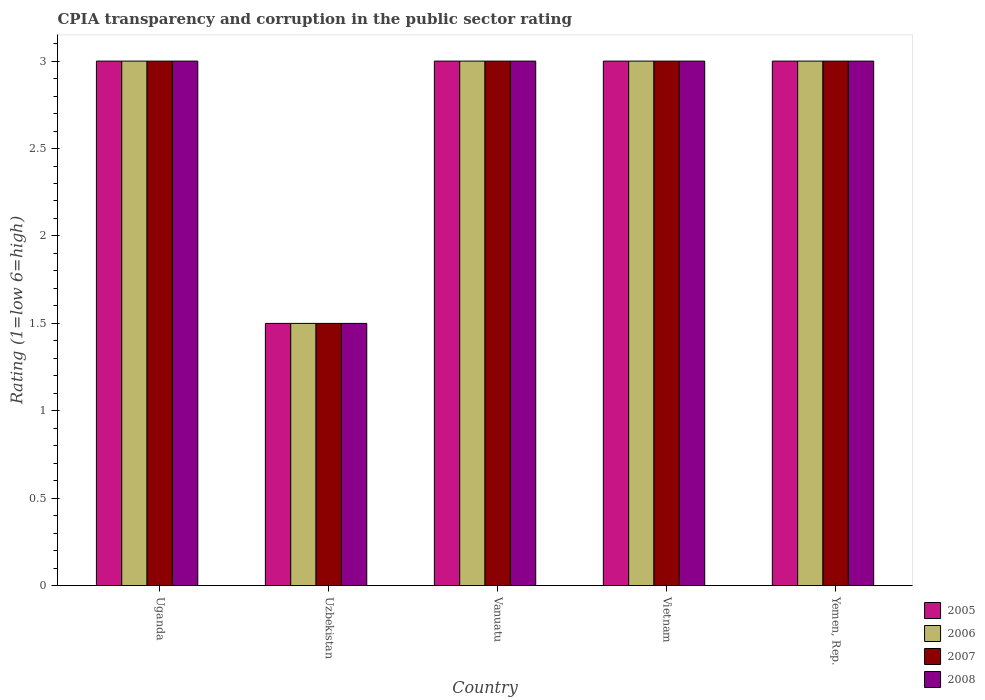How many different coloured bars are there?
Give a very brief answer. 4. Are the number of bars per tick equal to the number of legend labels?
Provide a succinct answer. Yes. How many bars are there on the 2nd tick from the left?
Your answer should be very brief. 4. How many bars are there on the 5th tick from the right?
Your answer should be very brief. 4. What is the label of the 2nd group of bars from the left?
Offer a very short reply. Uzbekistan. What is the CPIA rating in 2006 in Uganda?
Your answer should be very brief. 3. Across all countries, what is the maximum CPIA rating in 2006?
Your answer should be very brief. 3. Across all countries, what is the minimum CPIA rating in 2008?
Give a very brief answer. 1.5. In which country was the CPIA rating in 2007 maximum?
Make the answer very short. Uganda. In which country was the CPIA rating in 2007 minimum?
Give a very brief answer. Uzbekistan. What is the difference between the CPIA rating in 2007 in Yemen, Rep. and the CPIA rating in 2006 in Uzbekistan?
Keep it short and to the point. 1.5. In how many countries, is the CPIA rating in 2007 greater than 2.3?
Offer a very short reply. 4. What is the ratio of the CPIA rating in 2005 in Uganda to that in Vietnam?
Your answer should be very brief. 1. Is the CPIA rating in 2006 in Uganda less than that in Vietnam?
Offer a terse response. No. What is the difference between the highest and the lowest CPIA rating in 2005?
Give a very brief answer. 1.5. Is the sum of the CPIA rating in 2007 in Uganda and Uzbekistan greater than the maximum CPIA rating in 2006 across all countries?
Make the answer very short. Yes. How many bars are there?
Make the answer very short. 20. Are all the bars in the graph horizontal?
Offer a terse response. No. How many countries are there in the graph?
Give a very brief answer. 5. What is the difference between two consecutive major ticks on the Y-axis?
Provide a short and direct response. 0.5. Does the graph contain grids?
Give a very brief answer. No. How many legend labels are there?
Make the answer very short. 4. How are the legend labels stacked?
Make the answer very short. Vertical. What is the title of the graph?
Your answer should be compact. CPIA transparency and corruption in the public sector rating. Does "1989" appear as one of the legend labels in the graph?
Provide a short and direct response. No. What is the Rating (1=low 6=high) of 2005 in Uganda?
Give a very brief answer. 3. What is the Rating (1=low 6=high) in 2007 in Uganda?
Ensure brevity in your answer.  3. What is the Rating (1=low 6=high) in 2006 in Uzbekistan?
Your answer should be very brief. 1.5. What is the Rating (1=low 6=high) in 2005 in Vanuatu?
Give a very brief answer. 3. What is the Rating (1=low 6=high) of 2006 in Vanuatu?
Offer a very short reply. 3. What is the Rating (1=low 6=high) in 2007 in Vanuatu?
Your response must be concise. 3. What is the Rating (1=low 6=high) of 2008 in Vanuatu?
Offer a terse response. 3. What is the Rating (1=low 6=high) of 2007 in Vietnam?
Offer a terse response. 3. What is the Rating (1=low 6=high) in 2006 in Yemen, Rep.?
Provide a short and direct response. 3. Across all countries, what is the maximum Rating (1=low 6=high) of 2005?
Your answer should be very brief. 3. Across all countries, what is the maximum Rating (1=low 6=high) of 2007?
Ensure brevity in your answer.  3. Across all countries, what is the maximum Rating (1=low 6=high) of 2008?
Your response must be concise. 3. Across all countries, what is the minimum Rating (1=low 6=high) of 2005?
Keep it short and to the point. 1.5. Across all countries, what is the minimum Rating (1=low 6=high) in 2007?
Your answer should be compact. 1.5. Across all countries, what is the minimum Rating (1=low 6=high) of 2008?
Give a very brief answer. 1.5. What is the total Rating (1=low 6=high) of 2005 in the graph?
Offer a very short reply. 13.5. What is the total Rating (1=low 6=high) of 2006 in the graph?
Your answer should be compact. 13.5. What is the total Rating (1=low 6=high) in 2008 in the graph?
Make the answer very short. 13.5. What is the difference between the Rating (1=low 6=high) of 2006 in Uganda and that in Uzbekistan?
Offer a terse response. 1.5. What is the difference between the Rating (1=low 6=high) of 2007 in Uganda and that in Uzbekistan?
Provide a succinct answer. 1.5. What is the difference between the Rating (1=low 6=high) of 2008 in Uganda and that in Uzbekistan?
Give a very brief answer. 1.5. What is the difference between the Rating (1=low 6=high) in 2008 in Uganda and that in Vanuatu?
Your response must be concise. 0. What is the difference between the Rating (1=low 6=high) of 2006 in Uganda and that in Yemen, Rep.?
Ensure brevity in your answer.  0. What is the difference between the Rating (1=low 6=high) in 2007 in Uganda and that in Yemen, Rep.?
Ensure brevity in your answer.  0. What is the difference between the Rating (1=low 6=high) in 2008 in Uganda and that in Yemen, Rep.?
Your response must be concise. 0. What is the difference between the Rating (1=low 6=high) in 2006 in Uzbekistan and that in Vanuatu?
Offer a very short reply. -1.5. What is the difference between the Rating (1=low 6=high) of 2008 in Uzbekistan and that in Vanuatu?
Provide a short and direct response. -1.5. What is the difference between the Rating (1=low 6=high) in 2006 in Uzbekistan and that in Vietnam?
Your response must be concise. -1.5. What is the difference between the Rating (1=low 6=high) in 2006 in Uzbekistan and that in Yemen, Rep.?
Provide a succinct answer. -1.5. What is the difference between the Rating (1=low 6=high) of 2007 in Uzbekistan and that in Yemen, Rep.?
Keep it short and to the point. -1.5. What is the difference between the Rating (1=low 6=high) of 2006 in Vanuatu and that in Vietnam?
Keep it short and to the point. 0. What is the difference between the Rating (1=low 6=high) in 2007 in Vanuatu and that in Vietnam?
Keep it short and to the point. 0. What is the difference between the Rating (1=low 6=high) of 2008 in Vanuatu and that in Vietnam?
Your response must be concise. 0. What is the difference between the Rating (1=low 6=high) of 2005 in Vanuatu and that in Yemen, Rep.?
Give a very brief answer. 0. What is the difference between the Rating (1=low 6=high) in 2006 in Vanuatu and that in Yemen, Rep.?
Provide a short and direct response. 0. What is the difference between the Rating (1=low 6=high) in 2005 in Vietnam and that in Yemen, Rep.?
Keep it short and to the point. 0. What is the difference between the Rating (1=low 6=high) in 2006 in Vietnam and that in Yemen, Rep.?
Make the answer very short. 0. What is the difference between the Rating (1=low 6=high) of 2005 in Uganda and the Rating (1=low 6=high) of 2006 in Uzbekistan?
Your answer should be very brief. 1.5. What is the difference between the Rating (1=low 6=high) in 2005 in Uganda and the Rating (1=low 6=high) in 2008 in Uzbekistan?
Ensure brevity in your answer.  1.5. What is the difference between the Rating (1=low 6=high) in 2006 in Uganda and the Rating (1=low 6=high) in 2008 in Uzbekistan?
Your answer should be very brief. 1.5. What is the difference between the Rating (1=low 6=high) in 2007 in Uganda and the Rating (1=low 6=high) in 2008 in Uzbekistan?
Give a very brief answer. 1.5. What is the difference between the Rating (1=low 6=high) in 2005 in Uganda and the Rating (1=low 6=high) in 2006 in Vanuatu?
Ensure brevity in your answer.  0. What is the difference between the Rating (1=low 6=high) in 2005 in Uganda and the Rating (1=low 6=high) in 2008 in Vanuatu?
Ensure brevity in your answer.  0. What is the difference between the Rating (1=low 6=high) of 2006 in Uganda and the Rating (1=low 6=high) of 2008 in Vanuatu?
Keep it short and to the point. 0. What is the difference between the Rating (1=low 6=high) in 2005 in Uganda and the Rating (1=low 6=high) in 2008 in Vietnam?
Your answer should be very brief. 0. What is the difference between the Rating (1=low 6=high) of 2006 in Uganda and the Rating (1=low 6=high) of 2007 in Vietnam?
Ensure brevity in your answer.  0. What is the difference between the Rating (1=low 6=high) in 2006 in Uganda and the Rating (1=low 6=high) in 2008 in Vietnam?
Offer a terse response. 0. What is the difference between the Rating (1=low 6=high) in 2005 in Uganda and the Rating (1=low 6=high) in 2007 in Yemen, Rep.?
Make the answer very short. 0. What is the difference between the Rating (1=low 6=high) in 2005 in Uganda and the Rating (1=low 6=high) in 2008 in Yemen, Rep.?
Your response must be concise. 0. What is the difference between the Rating (1=low 6=high) of 2006 in Uganda and the Rating (1=low 6=high) of 2007 in Yemen, Rep.?
Your response must be concise. 0. What is the difference between the Rating (1=low 6=high) of 2006 in Uganda and the Rating (1=low 6=high) of 2008 in Yemen, Rep.?
Your answer should be very brief. 0. What is the difference between the Rating (1=low 6=high) of 2005 in Uzbekistan and the Rating (1=low 6=high) of 2007 in Vanuatu?
Your answer should be very brief. -1.5. What is the difference between the Rating (1=low 6=high) in 2005 in Uzbekistan and the Rating (1=low 6=high) in 2008 in Vanuatu?
Your answer should be compact. -1.5. What is the difference between the Rating (1=low 6=high) in 2006 in Uzbekistan and the Rating (1=low 6=high) in 2007 in Vanuatu?
Your answer should be very brief. -1.5. What is the difference between the Rating (1=low 6=high) of 2007 in Uzbekistan and the Rating (1=low 6=high) of 2008 in Vanuatu?
Provide a succinct answer. -1.5. What is the difference between the Rating (1=low 6=high) in 2005 in Uzbekistan and the Rating (1=low 6=high) in 2006 in Vietnam?
Offer a terse response. -1.5. What is the difference between the Rating (1=low 6=high) in 2005 in Uzbekistan and the Rating (1=low 6=high) in 2008 in Vietnam?
Provide a short and direct response. -1.5. What is the difference between the Rating (1=low 6=high) in 2006 in Uzbekistan and the Rating (1=low 6=high) in 2007 in Vietnam?
Offer a very short reply. -1.5. What is the difference between the Rating (1=low 6=high) in 2005 in Uzbekistan and the Rating (1=low 6=high) in 2007 in Yemen, Rep.?
Keep it short and to the point. -1.5. What is the difference between the Rating (1=low 6=high) of 2005 in Uzbekistan and the Rating (1=low 6=high) of 2008 in Yemen, Rep.?
Your answer should be very brief. -1.5. What is the difference between the Rating (1=low 6=high) in 2005 in Vanuatu and the Rating (1=low 6=high) in 2007 in Vietnam?
Ensure brevity in your answer.  0. What is the difference between the Rating (1=low 6=high) of 2005 in Vanuatu and the Rating (1=low 6=high) of 2008 in Vietnam?
Offer a very short reply. 0. What is the difference between the Rating (1=low 6=high) of 2006 in Vanuatu and the Rating (1=low 6=high) of 2007 in Vietnam?
Your answer should be compact. 0. What is the difference between the Rating (1=low 6=high) of 2007 in Vanuatu and the Rating (1=low 6=high) of 2008 in Vietnam?
Your response must be concise. 0. What is the difference between the Rating (1=low 6=high) of 2005 in Vanuatu and the Rating (1=low 6=high) of 2006 in Yemen, Rep.?
Your answer should be compact. 0. What is the difference between the Rating (1=low 6=high) of 2005 in Vanuatu and the Rating (1=low 6=high) of 2007 in Yemen, Rep.?
Make the answer very short. 0. What is the difference between the Rating (1=low 6=high) of 2005 in Vanuatu and the Rating (1=low 6=high) of 2008 in Yemen, Rep.?
Your response must be concise. 0. What is the difference between the Rating (1=low 6=high) in 2006 in Vanuatu and the Rating (1=low 6=high) in 2007 in Yemen, Rep.?
Make the answer very short. 0. What is the difference between the Rating (1=low 6=high) of 2006 in Vanuatu and the Rating (1=low 6=high) of 2008 in Yemen, Rep.?
Make the answer very short. 0. What is the difference between the Rating (1=low 6=high) of 2007 in Vanuatu and the Rating (1=low 6=high) of 2008 in Yemen, Rep.?
Give a very brief answer. 0. What is the difference between the Rating (1=low 6=high) in 2005 in Vietnam and the Rating (1=low 6=high) in 2006 in Yemen, Rep.?
Offer a very short reply. 0. What is the difference between the Rating (1=low 6=high) of 2006 in Vietnam and the Rating (1=low 6=high) of 2007 in Yemen, Rep.?
Offer a very short reply. 0. What is the difference between the Rating (1=low 6=high) in 2007 in Vietnam and the Rating (1=low 6=high) in 2008 in Yemen, Rep.?
Your answer should be compact. 0. What is the average Rating (1=low 6=high) in 2005 per country?
Offer a terse response. 2.7. What is the difference between the Rating (1=low 6=high) in 2005 and Rating (1=low 6=high) in 2006 in Uganda?
Offer a very short reply. 0. What is the difference between the Rating (1=low 6=high) in 2005 and Rating (1=low 6=high) in 2007 in Uganda?
Your answer should be compact. 0. What is the difference between the Rating (1=low 6=high) of 2007 and Rating (1=low 6=high) of 2008 in Uganda?
Provide a succinct answer. 0. What is the difference between the Rating (1=low 6=high) in 2005 and Rating (1=low 6=high) in 2006 in Uzbekistan?
Ensure brevity in your answer.  0. What is the difference between the Rating (1=low 6=high) of 2005 and Rating (1=low 6=high) of 2007 in Uzbekistan?
Your answer should be compact. 0. What is the difference between the Rating (1=low 6=high) of 2005 and Rating (1=low 6=high) of 2008 in Uzbekistan?
Offer a very short reply. 0. What is the difference between the Rating (1=low 6=high) in 2006 and Rating (1=low 6=high) in 2008 in Uzbekistan?
Keep it short and to the point. 0. What is the difference between the Rating (1=low 6=high) in 2005 and Rating (1=low 6=high) in 2007 in Vanuatu?
Keep it short and to the point. 0. What is the difference between the Rating (1=low 6=high) in 2005 and Rating (1=low 6=high) in 2008 in Vietnam?
Your answer should be very brief. 0. What is the difference between the Rating (1=low 6=high) of 2006 and Rating (1=low 6=high) of 2007 in Vietnam?
Offer a very short reply. 0. What is the difference between the Rating (1=low 6=high) in 2006 and Rating (1=low 6=high) in 2008 in Vietnam?
Offer a terse response. 0. What is the difference between the Rating (1=low 6=high) of 2005 and Rating (1=low 6=high) of 2006 in Yemen, Rep.?
Give a very brief answer. 0. What is the difference between the Rating (1=low 6=high) of 2005 and Rating (1=low 6=high) of 2008 in Yemen, Rep.?
Your response must be concise. 0. What is the difference between the Rating (1=low 6=high) in 2006 and Rating (1=low 6=high) in 2007 in Yemen, Rep.?
Offer a terse response. 0. What is the difference between the Rating (1=low 6=high) in 2007 and Rating (1=low 6=high) in 2008 in Yemen, Rep.?
Keep it short and to the point. 0. What is the ratio of the Rating (1=low 6=high) of 2005 in Uganda to that in Uzbekistan?
Make the answer very short. 2. What is the ratio of the Rating (1=low 6=high) of 2006 in Uganda to that in Uzbekistan?
Offer a terse response. 2. What is the ratio of the Rating (1=low 6=high) in 2008 in Uganda to that in Uzbekistan?
Offer a terse response. 2. What is the ratio of the Rating (1=low 6=high) in 2005 in Uganda to that in Vanuatu?
Provide a succinct answer. 1. What is the ratio of the Rating (1=low 6=high) in 2007 in Uganda to that in Vanuatu?
Offer a terse response. 1. What is the ratio of the Rating (1=low 6=high) of 2008 in Uganda to that in Vanuatu?
Your response must be concise. 1. What is the ratio of the Rating (1=low 6=high) in 2005 in Uganda to that in Yemen, Rep.?
Offer a very short reply. 1. What is the ratio of the Rating (1=low 6=high) in 2007 in Uganda to that in Yemen, Rep.?
Provide a succinct answer. 1. What is the ratio of the Rating (1=low 6=high) of 2008 in Uganda to that in Yemen, Rep.?
Offer a terse response. 1. What is the ratio of the Rating (1=low 6=high) in 2005 in Uzbekistan to that in Vanuatu?
Your answer should be compact. 0.5. What is the ratio of the Rating (1=low 6=high) of 2008 in Uzbekistan to that in Vanuatu?
Offer a terse response. 0.5. What is the ratio of the Rating (1=low 6=high) in 2005 in Uzbekistan to that in Vietnam?
Make the answer very short. 0.5. What is the ratio of the Rating (1=low 6=high) of 2006 in Uzbekistan to that in Vietnam?
Offer a very short reply. 0.5. What is the ratio of the Rating (1=low 6=high) in 2008 in Uzbekistan to that in Vietnam?
Give a very brief answer. 0.5. What is the ratio of the Rating (1=low 6=high) of 2007 in Uzbekistan to that in Yemen, Rep.?
Offer a very short reply. 0.5. What is the ratio of the Rating (1=low 6=high) of 2008 in Uzbekistan to that in Yemen, Rep.?
Your answer should be compact. 0.5. What is the ratio of the Rating (1=low 6=high) in 2007 in Vanuatu to that in Vietnam?
Give a very brief answer. 1. What is the ratio of the Rating (1=low 6=high) of 2008 in Vanuatu to that in Vietnam?
Give a very brief answer. 1. What is the ratio of the Rating (1=low 6=high) of 2007 in Vanuatu to that in Yemen, Rep.?
Keep it short and to the point. 1. What is the ratio of the Rating (1=low 6=high) in 2006 in Vietnam to that in Yemen, Rep.?
Offer a terse response. 1. What is the difference between the highest and the second highest Rating (1=low 6=high) in 2005?
Offer a terse response. 0. What is the difference between the highest and the second highest Rating (1=low 6=high) in 2006?
Provide a short and direct response. 0. What is the difference between the highest and the second highest Rating (1=low 6=high) of 2007?
Ensure brevity in your answer.  0. What is the difference between the highest and the second highest Rating (1=low 6=high) of 2008?
Ensure brevity in your answer.  0. What is the difference between the highest and the lowest Rating (1=low 6=high) of 2005?
Your answer should be very brief. 1.5. What is the difference between the highest and the lowest Rating (1=low 6=high) in 2006?
Your response must be concise. 1.5. What is the difference between the highest and the lowest Rating (1=low 6=high) of 2007?
Provide a short and direct response. 1.5. What is the difference between the highest and the lowest Rating (1=low 6=high) in 2008?
Ensure brevity in your answer.  1.5. 